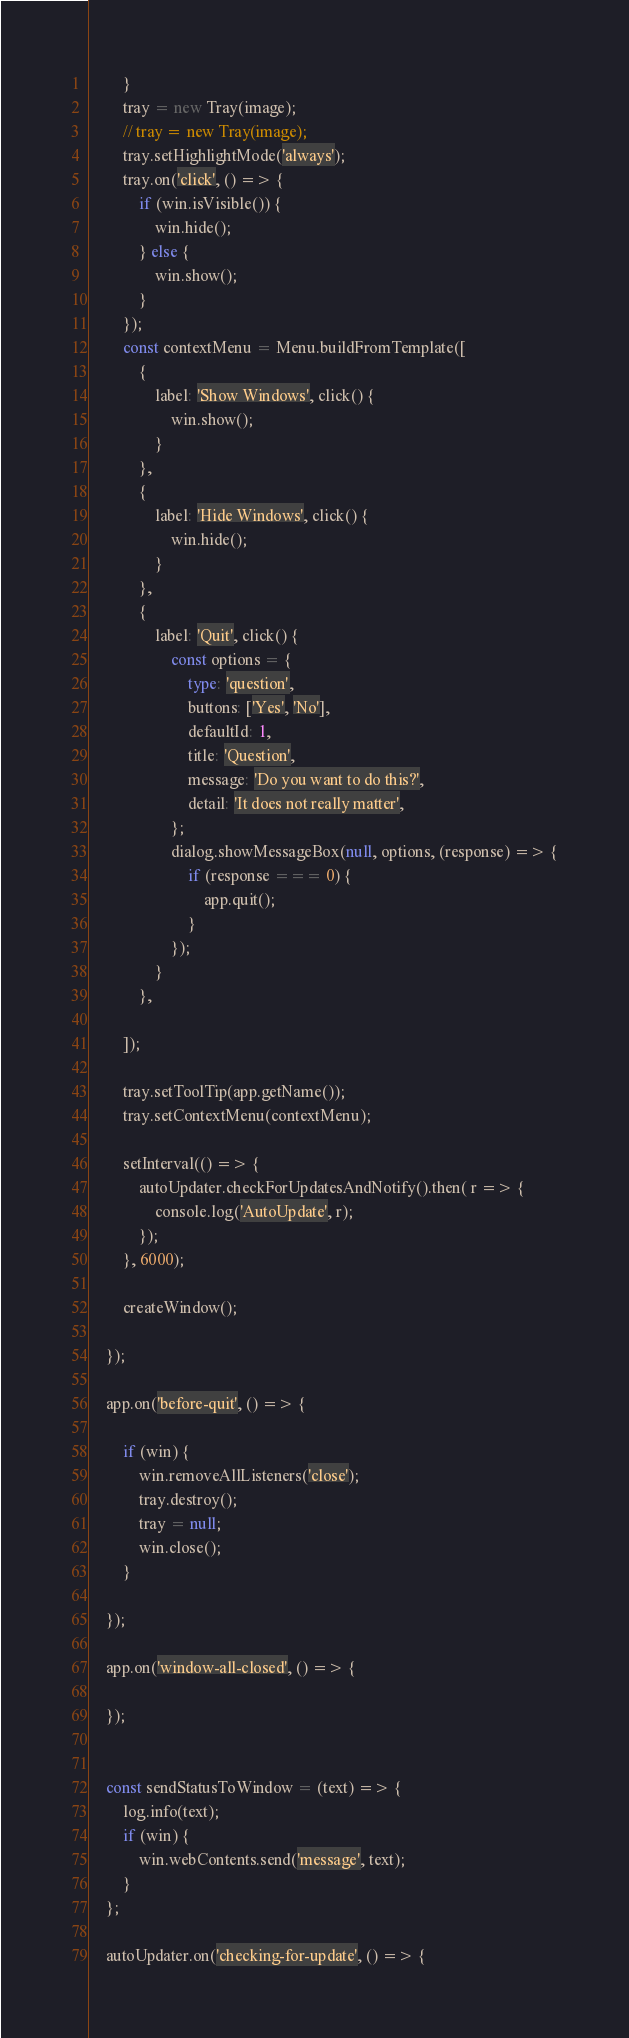Convert code to text. <code><loc_0><loc_0><loc_500><loc_500><_TypeScript_>        }
        tray = new Tray(image);
        // tray = new Tray(image);
        tray.setHighlightMode('always');
        tray.on('click', () => {
            if (win.isVisible()) {
                win.hide();
            } else {
                win.show();
            }
        });
        const contextMenu = Menu.buildFromTemplate([
            {
                label: 'Show Windows', click() {
                    win.show();
                }
            },
            {
                label: 'Hide Windows', click() {
                    win.hide();
                }
            },
            {
                label: 'Quit', click() {
                    const options = {
                        type: 'question',
                        buttons: ['Yes', 'No'],
                        defaultId: 1,
                        title: 'Question',
                        message: 'Do you want to do this?',
                        detail: 'It does not really matter',
                    };
                    dialog.showMessageBox(null, options, (response) => {
                        if (response === 0) {
                            app.quit();
                        }
                    });
                }
            },

        ]);

        tray.setToolTip(app.getName());
        tray.setContextMenu(contextMenu);

        setInterval(() => {
            autoUpdater.checkForUpdatesAndNotify().then( r => {
                console.log('AutoUpdate', r);
            });
        }, 6000);

        createWindow();

    });

    app.on('before-quit', () => {

        if (win) {
            win.removeAllListeners('close');
            tray.destroy();
            tray = null;
            win.close();
        }

    });

    app.on('window-all-closed', () => {

    });


    const sendStatusToWindow = (text) => {
        log.info(text);
        if (win) {
            win.webContents.send('message', text);
        }
    };

    autoUpdater.on('checking-for-update', () => {</code> 